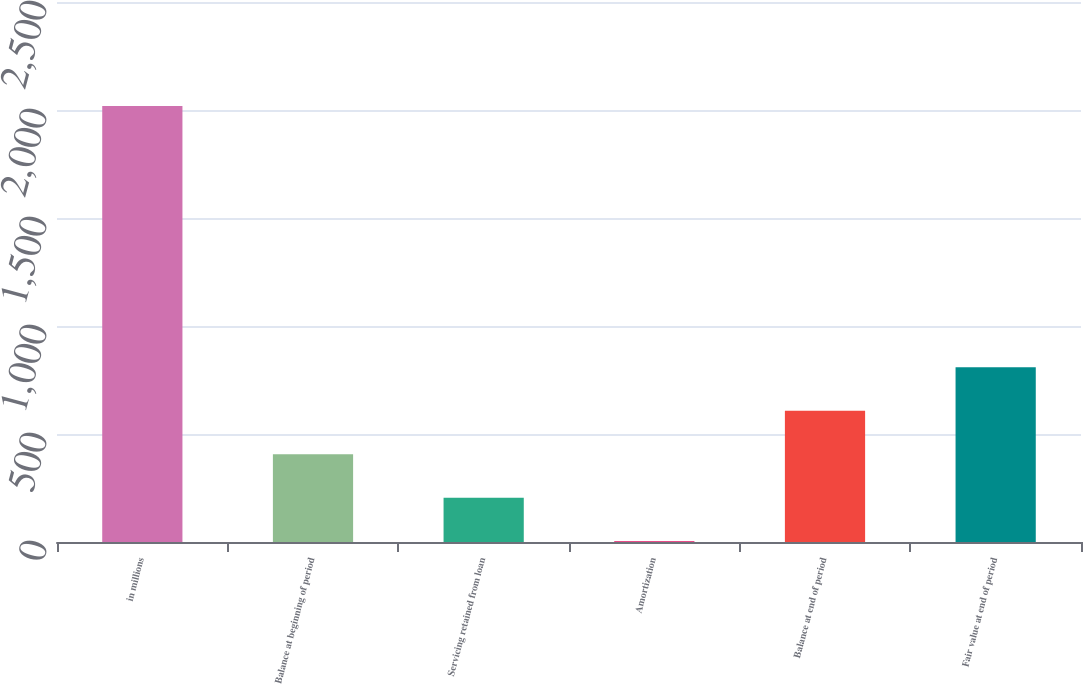Convert chart to OTSL. <chart><loc_0><loc_0><loc_500><loc_500><bar_chart><fcel>in millions<fcel>Balance at beginning of period<fcel>Servicing retained from loan<fcel>Amortization<fcel>Balance at end of period<fcel>Fair value at end of period<nl><fcel>2018<fcel>406.8<fcel>205.4<fcel>4<fcel>608.2<fcel>809.6<nl></chart> 